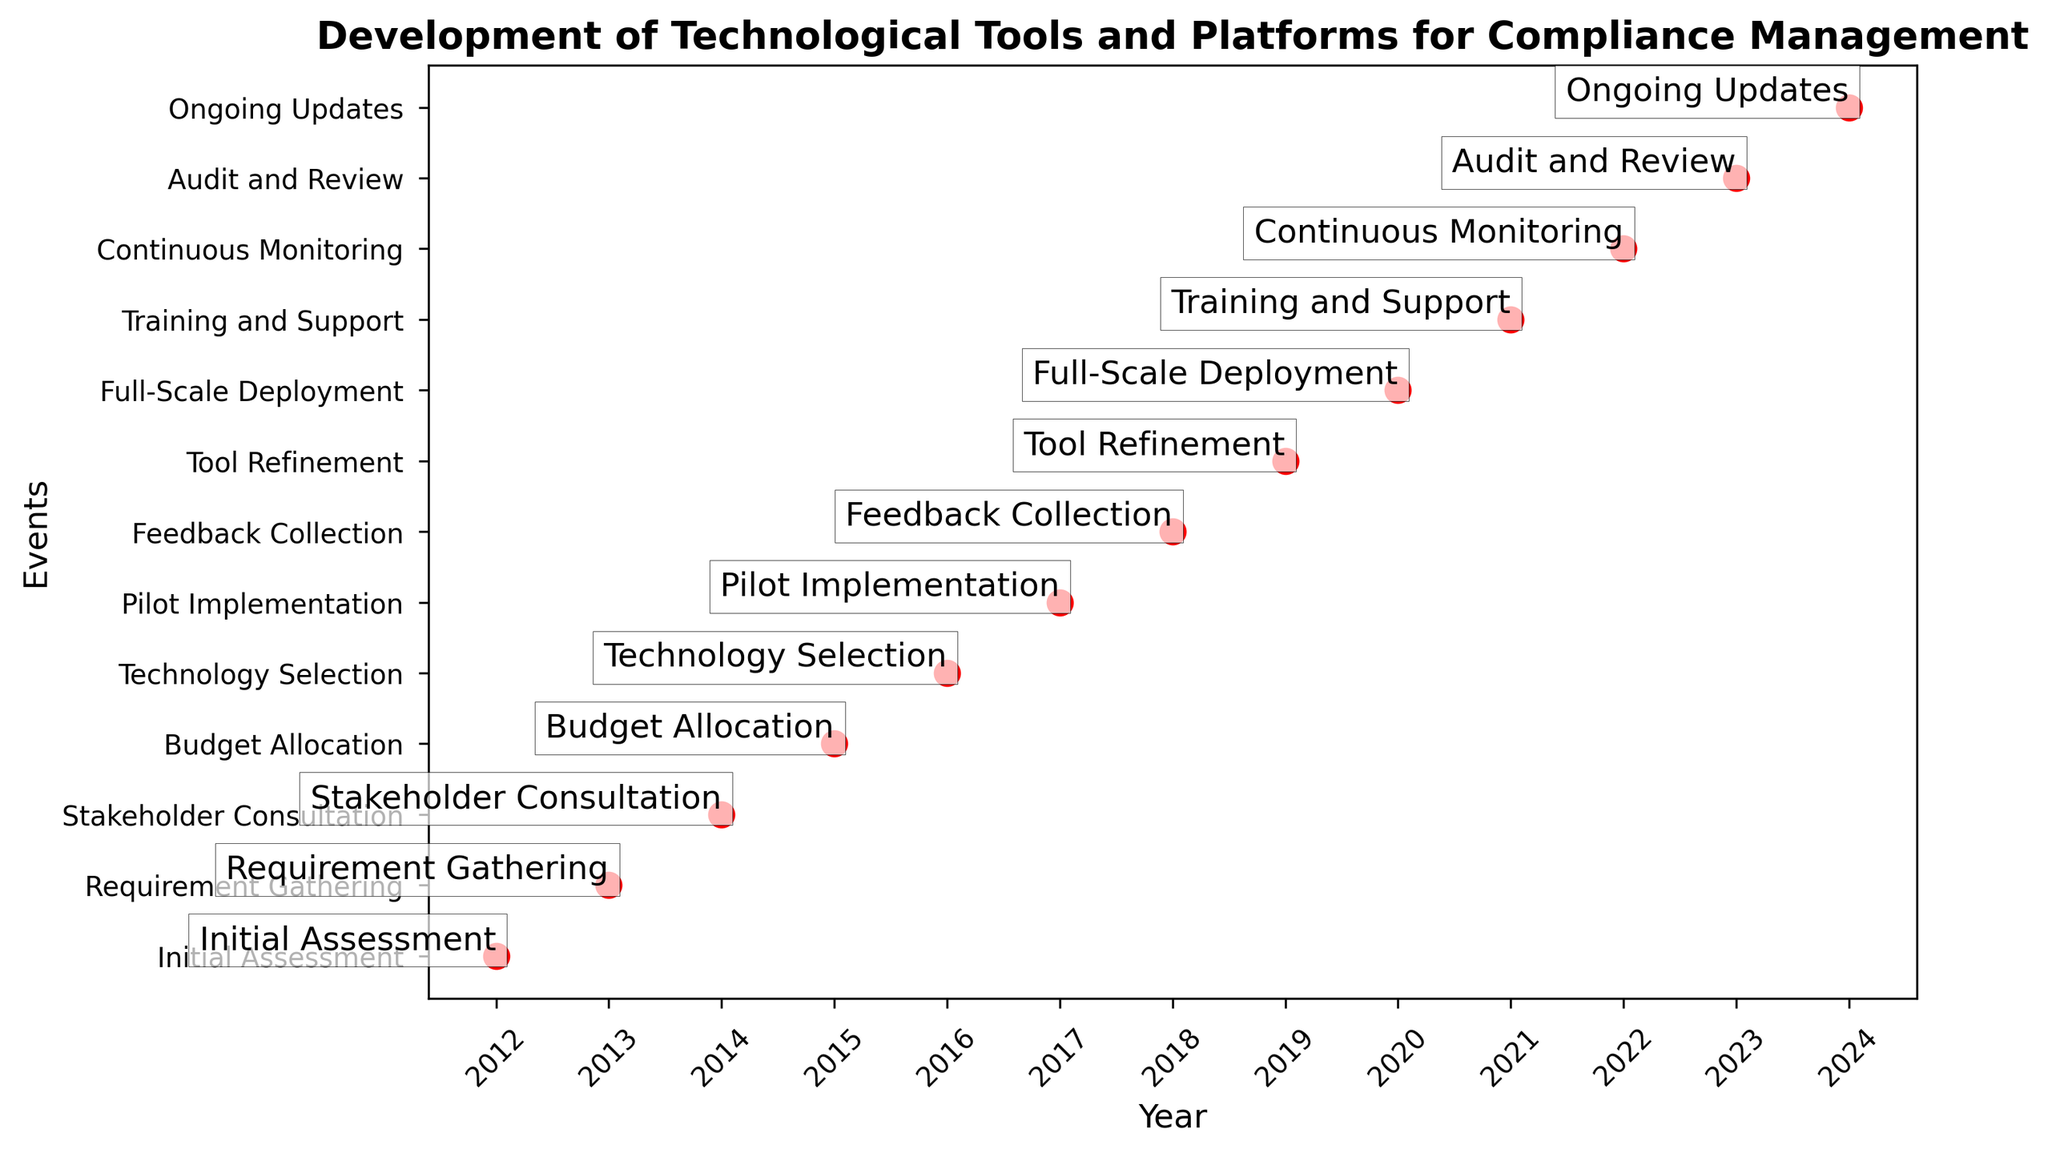What year was the Initial Assessment conducted? Look at the timeline to find the year corresponding to the "Initial Assessment" event, which is at the beginning.
Answer: 2012 In which year did the Training and Support for staff occur? Check the timeline for when the "Training and Support" event took place, which is near the end of the timeline.
Answer: 2021 Which event took place in 2019? Locate 2019 on the timeline and identify the corresponding event labeled for that year.
Answer: Tool Refinement How many years passed between the Pilot Implementation and the Full-Scale Deployment? Find the years for "Pilot Implementation" and "Full-Scale Deployment" and calculate the difference between them. The events occurred in 2017 and 2020 respectively, so (2020 - 2017).
Answer: 3 years List all the events that happened before 2016. Identify all events that occurred before the year 2016 from the timeline, which are before the "Technology Selection" event.
Answer: Initial Assessment, Requirement Gathering, Stakeholder Consultation, Budget Allocation Which event occurred last in the series? Identify the final event on the timeline, which is positioned after all other events.
Answer: Ongoing Updates What is the difference in years between the Budget Allocation and the Continuous Monitoring? Find the years for both events: "Budget Allocation" in 2015 and "Continuous Monitoring" in 2022. Calculate the difference, (2022 - 2015).
Answer: 7 years What is the middle event in the timeline? With an even total number of events (13), there is no single middle event, but the 7th and 8th events are central. Identify 7th and 8th events in the timeline.
Answer: Feedback Collection and Tool Refinement Which event required stakeholder consultation and happened before Budget Allocation? Find "Stakeholder Consultation" on the timeline, check its positioning relative to the "Budget Allocation" event. "Stakeholder Consultation" is in 2014, and it is before the 2015 event.
Answer: Stakeholder Consultation How many events required changes or modifications based on feedback? Count the events that mention feedback or refinement in their descriptions on the timeline. Feedback Collection in 2018 and Tool Refinement in 2019 are such events.
Answer: 2 events 